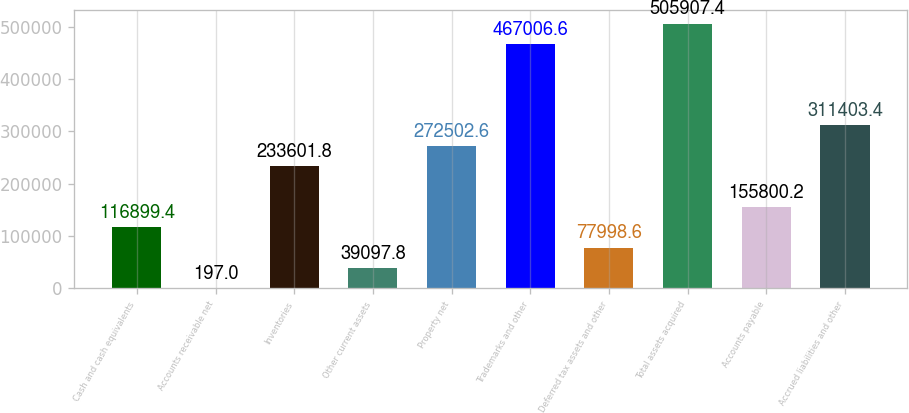Convert chart. <chart><loc_0><loc_0><loc_500><loc_500><bar_chart><fcel>Cash and cash equivalents<fcel>Accounts receivable net<fcel>Inventories<fcel>Other current assets<fcel>Property net<fcel>Trademarks and other<fcel>Deferred tax assets and other<fcel>Total assets acquired<fcel>Accounts payable<fcel>Accrued liabilities and other<nl><fcel>116899<fcel>197<fcel>233602<fcel>39097.8<fcel>272503<fcel>467007<fcel>77998.6<fcel>505907<fcel>155800<fcel>311403<nl></chart> 